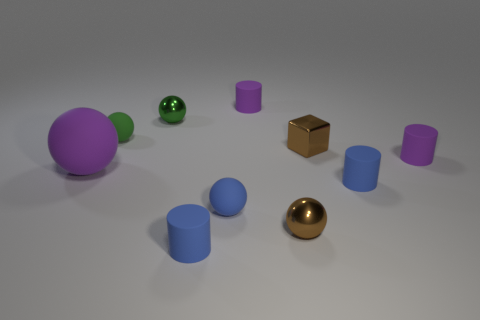How many small matte cylinders are right of the blue matte sphere?
Offer a very short reply. 3. What number of other objects are the same size as the blue ball?
Give a very brief answer. 8. What is the size of the purple thing that is the same shape as the green metallic thing?
Your answer should be very brief. Large. What shape is the tiny blue thing that is in front of the tiny blue rubber ball?
Provide a short and direct response. Cylinder. The metal sphere that is behind the tiny brown metal object that is behind the large matte thing is what color?
Provide a short and direct response. Green. How many objects are either tiny purple matte cylinders that are right of the small block or green spheres?
Give a very brief answer. 3. There is a green shiny thing; is it the same size as the blue thing to the right of the shiny cube?
Your answer should be compact. Yes. What number of tiny things are either green metal spheres or spheres?
Provide a short and direct response. 4. The green metal object is what shape?
Your answer should be compact. Sphere. What size is the thing that is the same color as the tiny cube?
Make the answer very short. Small. 